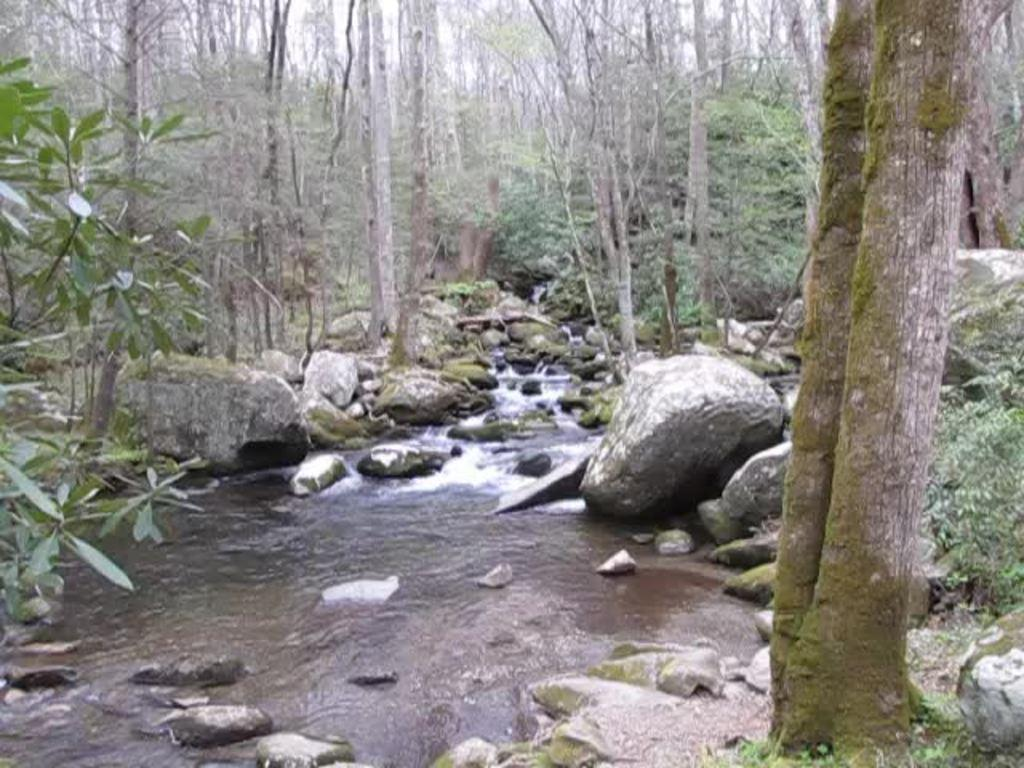What type of natural elements can be seen in the image? There are stones, water, and trees visible in the image. Can you describe the water in the image? The water is visible in the image, but its specific characteristics are not mentioned. What type of vegetation is present in the image? Trees are present in the image. How many pieces of beef can be seen in the image? There is no beef present in the image. What type of spiders are crawling on the trees in the image? There are no spiders visible in the image. 